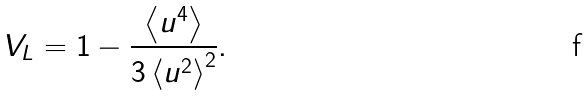<formula> <loc_0><loc_0><loc_500><loc_500>V _ { L } = 1 - \frac { \left < u ^ { 4 } \right > } { 3 \left < u ^ { 2 } \right > ^ { 2 } } .</formula> 